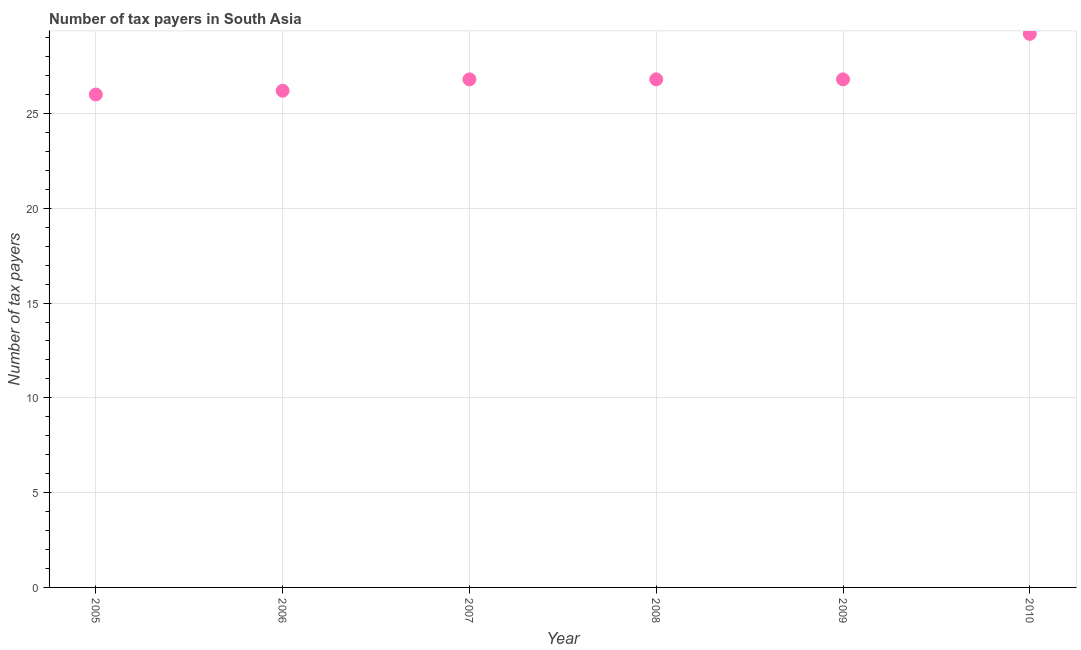What is the number of tax payers in 2008?
Your answer should be compact. 26.8. Across all years, what is the maximum number of tax payers?
Offer a terse response. 29.2. Across all years, what is the minimum number of tax payers?
Keep it short and to the point. 26. In which year was the number of tax payers maximum?
Ensure brevity in your answer.  2010. In which year was the number of tax payers minimum?
Ensure brevity in your answer.  2005. What is the sum of the number of tax payers?
Your answer should be compact. 161.8. What is the difference between the number of tax payers in 2006 and 2008?
Offer a very short reply. -0.6. What is the average number of tax payers per year?
Your response must be concise. 26.97. What is the median number of tax payers?
Provide a succinct answer. 26.8. In how many years, is the number of tax payers greater than 6 ?
Provide a short and direct response. 6. What is the ratio of the number of tax payers in 2007 to that in 2010?
Provide a succinct answer. 0.92. Is the number of tax payers in 2006 less than that in 2008?
Your answer should be compact. Yes. What is the difference between the highest and the second highest number of tax payers?
Your response must be concise. 2.4. Is the sum of the number of tax payers in 2006 and 2008 greater than the maximum number of tax payers across all years?
Provide a short and direct response. Yes. What is the difference between the highest and the lowest number of tax payers?
Offer a very short reply. 3.2. Does the number of tax payers monotonically increase over the years?
Give a very brief answer. No. What is the difference between two consecutive major ticks on the Y-axis?
Make the answer very short. 5. Does the graph contain grids?
Make the answer very short. Yes. What is the title of the graph?
Offer a terse response. Number of tax payers in South Asia. What is the label or title of the X-axis?
Ensure brevity in your answer.  Year. What is the label or title of the Y-axis?
Keep it short and to the point. Number of tax payers. What is the Number of tax payers in 2005?
Provide a short and direct response. 26. What is the Number of tax payers in 2006?
Provide a succinct answer. 26.2. What is the Number of tax payers in 2007?
Offer a terse response. 26.8. What is the Number of tax payers in 2008?
Ensure brevity in your answer.  26.8. What is the Number of tax payers in 2009?
Offer a very short reply. 26.8. What is the Number of tax payers in 2010?
Your answer should be compact. 29.2. What is the difference between the Number of tax payers in 2005 and 2008?
Your answer should be compact. -0.8. What is the difference between the Number of tax payers in 2005 and 2010?
Offer a very short reply. -3.2. What is the difference between the Number of tax payers in 2006 and 2008?
Give a very brief answer. -0.6. What is the difference between the Number of tax payers in 2006 and 2009?
Offer a very short reply. -0.6. What is the difference between the Number of tax payers in 2006 and 2010?
Your response must be concise. -3. What is the difference between the Number of tax payers in 2007 and 2008?
Offer a terse response. 0. What is the difference between the Number of tax payers in 2007 and 2009?
Offer a very short reply. 0. What is the difference between the Number of tax payers in 2007 and 2010?
Provide a succinct answer. -2.4. What is the difference between the Number of tax payers in 2008 and 2009?
Make the answer very short. 0. What is the difference between the Number of tax payers in 2009 and 2010?
Provide a short and direct response. -2.4. What is the ratio of the Number of tax payers in 2005 to that in 2006?
Give a very brief answer. 0.99. What is the ratio of the Number of tax payers in 2005 to that in 2007?
Ensure brevity in your answer.  0.97. What is the ratio of the Number of tax payers in 2005 to that in 2009?
Your answer should be compact. 0.97. What is the ratio of the Number of tax payers in 2005 to that in 2010?
Your answer should be compact. 0.89. What is the ratio of the Number of tax payers in 2006 to that in 2010?
Provide a short and direct response. 0.9. What is the ratio of the Number of tax payers in 2007 to that in 2009?
Provide a succinct answer. 1. What is the ratio of the Number of tax payers in 2007 to that in 2010?
Ensure brevity in your answer.  0.92. What is the ratio of the Number of tax payers in 2008 to that in 2009?
Your response must be concise. 1. What is the ratio of the Number of tax payers in 2008 to that in 2010?
Your answer should be very brief. 0.92. What is the ratio of the Number of tax payers in 2009 to that in 2010?
Provide a succinct answer. 0.92. 